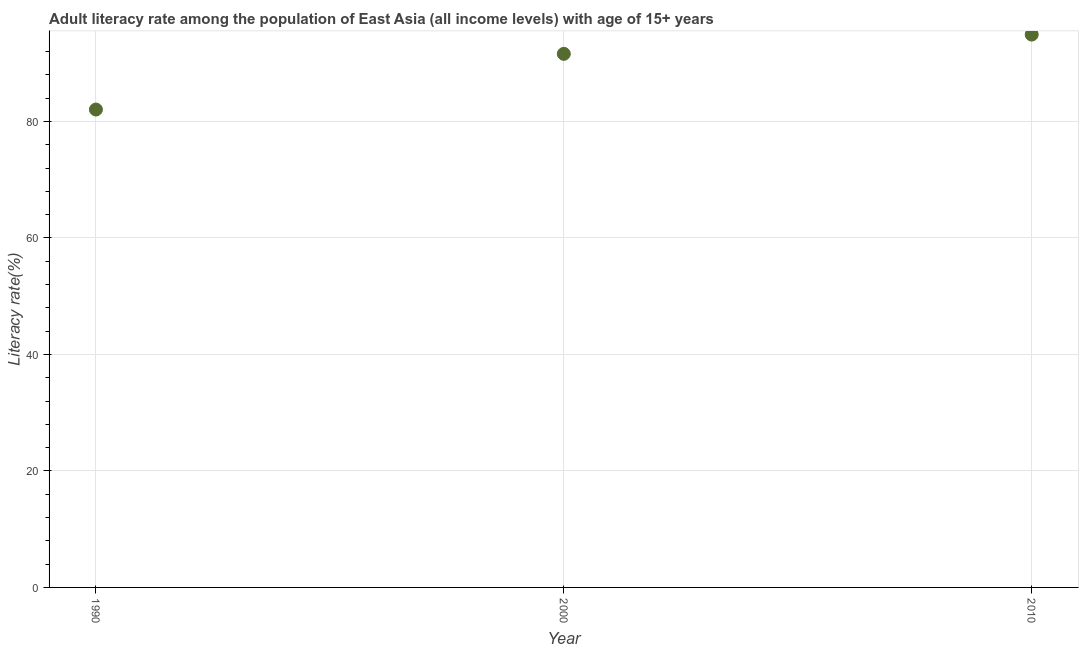What is the adult literacy rate in 1990?
Your response must be concise. 82.05. Across all years, what is the maximum adult literacy rate?
Keep it short and to the point. 94.92. Across all years, what is the minimum adult literacy rate?
Make the answer very short. 82.05. In which year was the adult literacy rate minimum?
Your answer should be compact. 1990. What is the sum of the adult literacy rate?
Your answer should be very brief. 268.59. What is the difference between the adult literacy rate in 1990 and 2000?
Keep it short and to the point. -9.56. What is the average adult literacy rate per year?
Your answer should be very brief. 89.53. What is the median adult literacy rate?
Keep it short and to the point. 91.61. What is the ratio of the adult literacy rate in 2000 to that in 2010?
Provide a short and direct response. 0.97. Is the difference between the adult literacy rate in 1990 and 2000 greater than the difference between any two years?
Keep it short and to the point. No. What is the difference between the highest and the second highest adult literacy rate?
Make the answer very short. 3.31. What is the difference between the highest and the lowest adult literacy rate?
Your response must be concise. 12.87. Does the adult literacy rate monotonically increase over the years?
Provide a succinct answer. Yes. How many dotlines are there?
Your answer should be compact. 1. Are the values on the major ticks of Y-axis written in scientific E-notation?
Your answer should be compact. No. Does the graph contain any zero values?
Keep it short and to the point. No. What is the title of the graph?
Ensure brevity in your answer.  Adult literacy rate among the population of East Asia (all income levels) with age of 15+ years. What is the label or title of the Y-axis?
Offer a terse response. Literacy rate(%). What is the Literacy rate(%) in 1990?
Your answer should be very brief. 82.05. What is the Literacy rate(%) in 2000?
Your answer should be compact. 91.61. What is the Literacy rate(%) in 2010?
Provide a succinct answer. 94.92. What is the difference between the Literacy rate(%) in 1990 and 2000?
Offer a terse response. -9.56. What is the difference between the Literacy rate(%) in 1990 and 2010?
Offer a terse response. -12.87. What is the difference between the Literacy rate(%) in 2000 and 2010?
Make the answer very short. -3.31. What is the ratio of the Literacy rate(%) in 1990 to that in 2000?
Offer a very short reply. 0.9. What is the ratio of the Literacy rate(%) in 1990 to that in 2010?
Offer a very short reply. 0.86. 